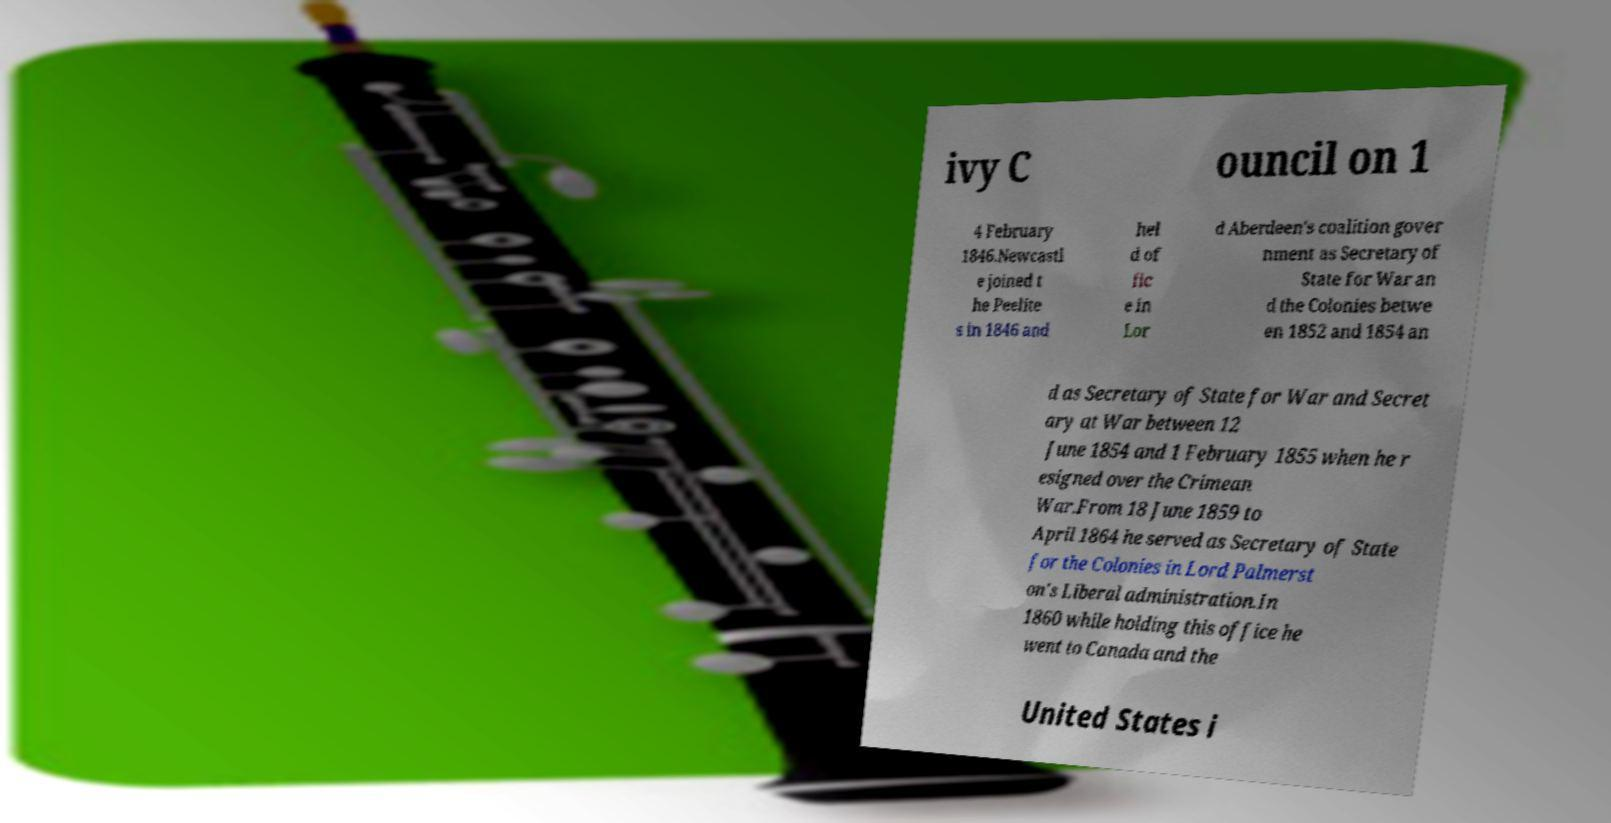For documentation purposes, I need the text within this image transcribed. Could you provide that? ivy C ouncil on 1 4 February 1846.Newcastl e joined t he Peelite s in 1846 and hel d of fic e in Lor d Aberdeen's coalition gover nment as Secretary of State for War an d the Colonies betwe en 1852 and 1854 an d as Secretary of State for War and Secret ary at War between 12 June 1854 and 1 February 1855 when he r esigned over the Crimean War.From 18 June 1859 to April 1864 he served as Secretary of State for the Colonies in Lord Palmerst on's Liberal administration.In 1860 while holding this office he went to Canada and the United States i 